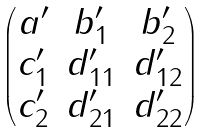<formula> <loc_0><loc_0><loc_500><loc_500>\begin{pmatrix} a ^ { \prime } & b ^ { \prime } _ { 1 } & b ^ { \prime } _ { 2 } \\ c ^ { \prime } _ { 1 } & d ^ { \prime } _ { 1 1 } & d ^ { \prime } _ { 1 2 } \\ c ^ { \prime } _ { 2 } & d ^ { \prime } _ { 2 1 } & d ^ { \prime } _ { 2 2 } \end{pmatrix}</formula> 